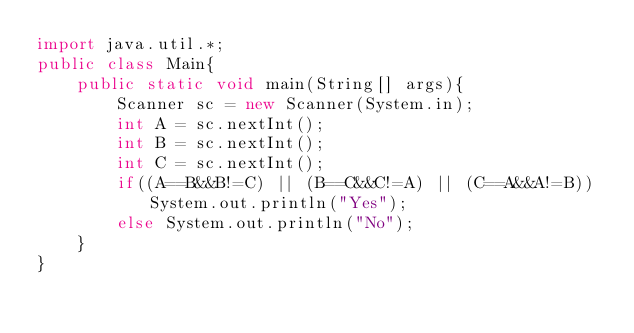Convert code to text. <code><loc_0><loc_0><loc_500><loc_500><_Java_>import java.util.*;
public class Main{
	public static void main(String[] args){
    	Scanner sc = new Scanner(System.in);
      	int A = sc.nextInt();
      	int B = sc.nextInt();
      	int C = sc.nextInt();
      	if((A==B&&B!=C) || (B==C&&C!=A) || (C==A&&A!=B)) System.out.println("Yes");
      	else System.out.println("No");
    }
}</code> 